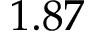Convert formula to latex. <formula><loc_0><loc_0><loc_500><loc_500>1 . 8 7</formula> 